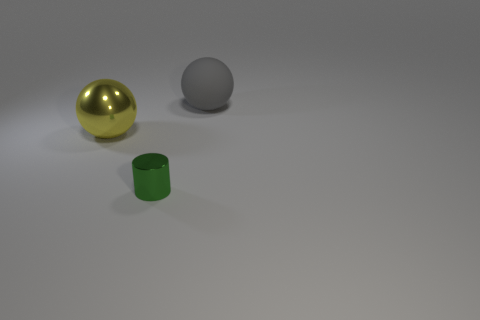Add 1 gray matte things. How many objects exist? 4 Subtract all yellow balls. How many balls are left? 1 Subtract all spheres. How many objects are left? 1 Add 3 metal balls. How many metal balls are left? 4 Add 3 tiny metallic cylinders. How many tiny metallic cylinders exist? 4 Subtract 0 cyan cylinders. How many objects are left? 3 Subtract all blue spheres. Subtract all purple cylinders. How many spheres are left? 2 Subtract all big red rubber cylinders. Subtract all metal balls. How many objects are left? 2 